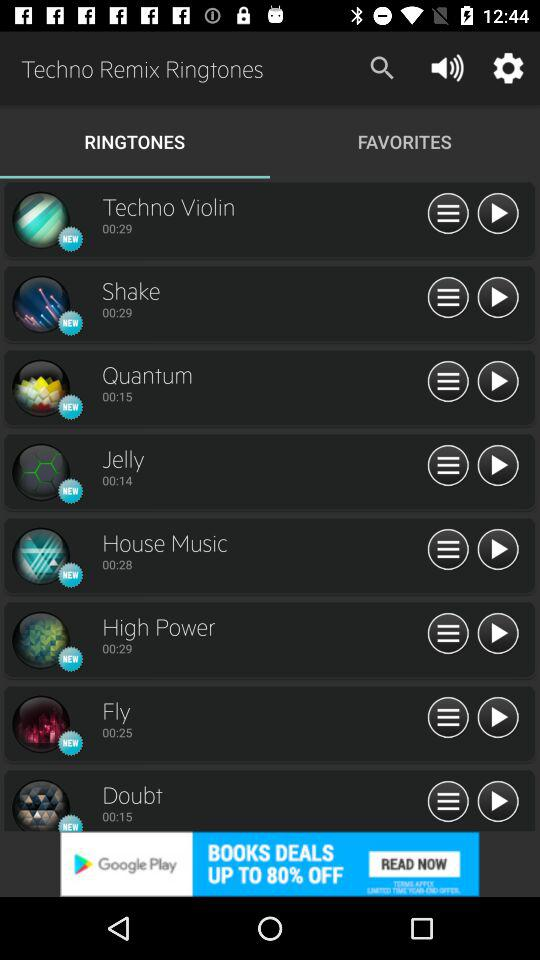What is the duration of the ringtone "Jelly"? The duration is 14 seconds. 